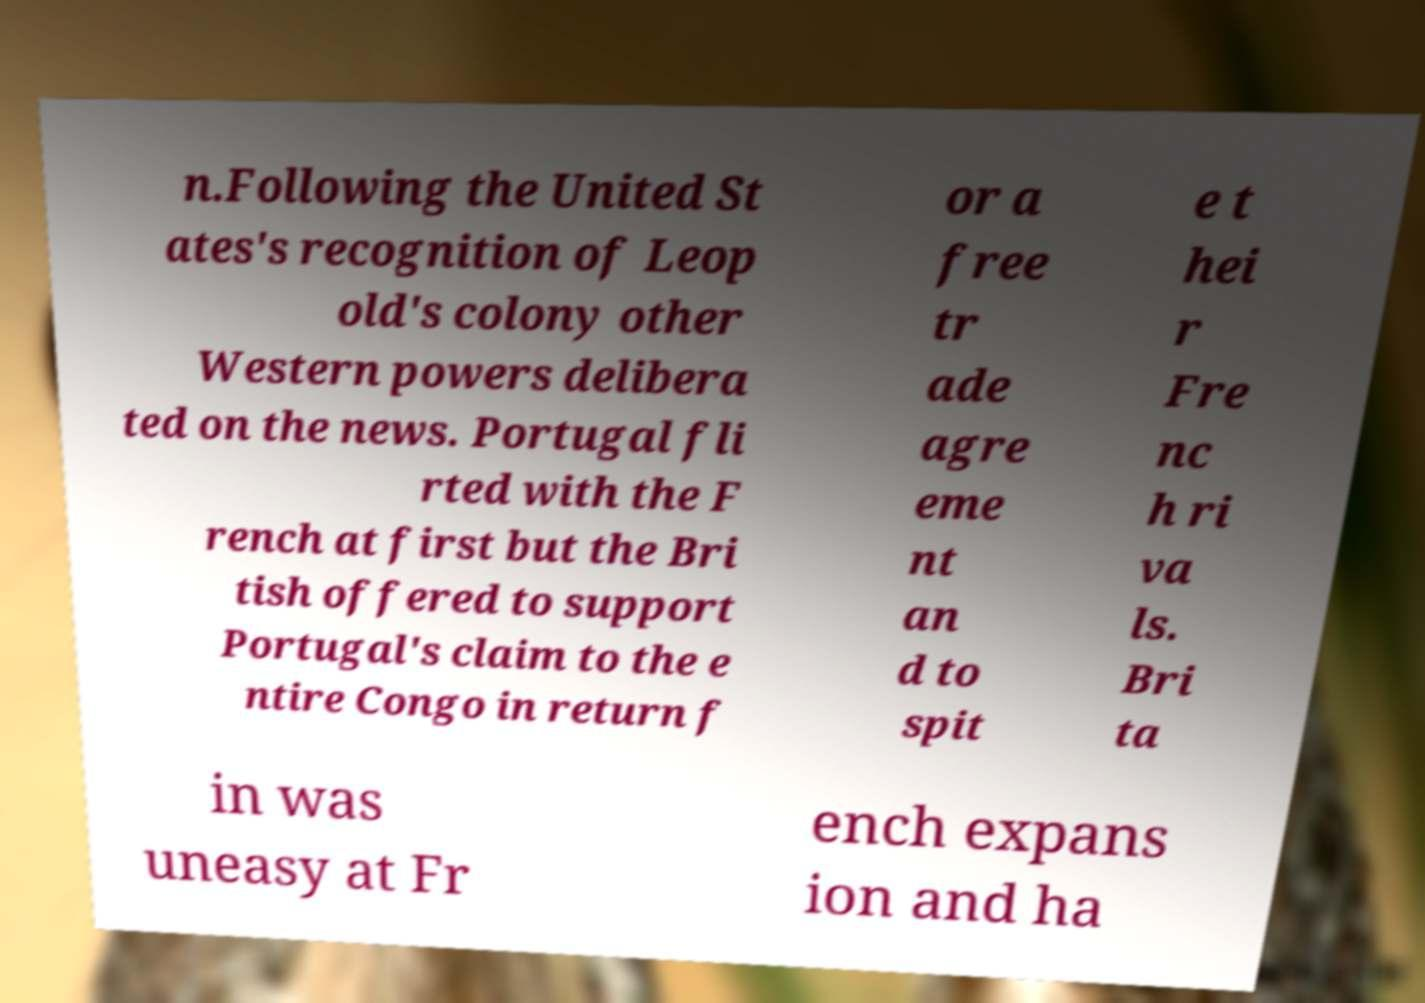Can you accurately transcribe the text from the provided image for me? n.Following the United St ates's recognition of Leop old's colony other Western powers delibera ted on the news. Portugal fli rted with the F rench at first but the Bri tish offered to support Portugal's claim to the e ntire Congo in return f or a free tr ade agre eme nt an d to spit e t hei r Fre nc h ri va ls. Bri ta in was uneasy at Fr ench expans ion and ha 